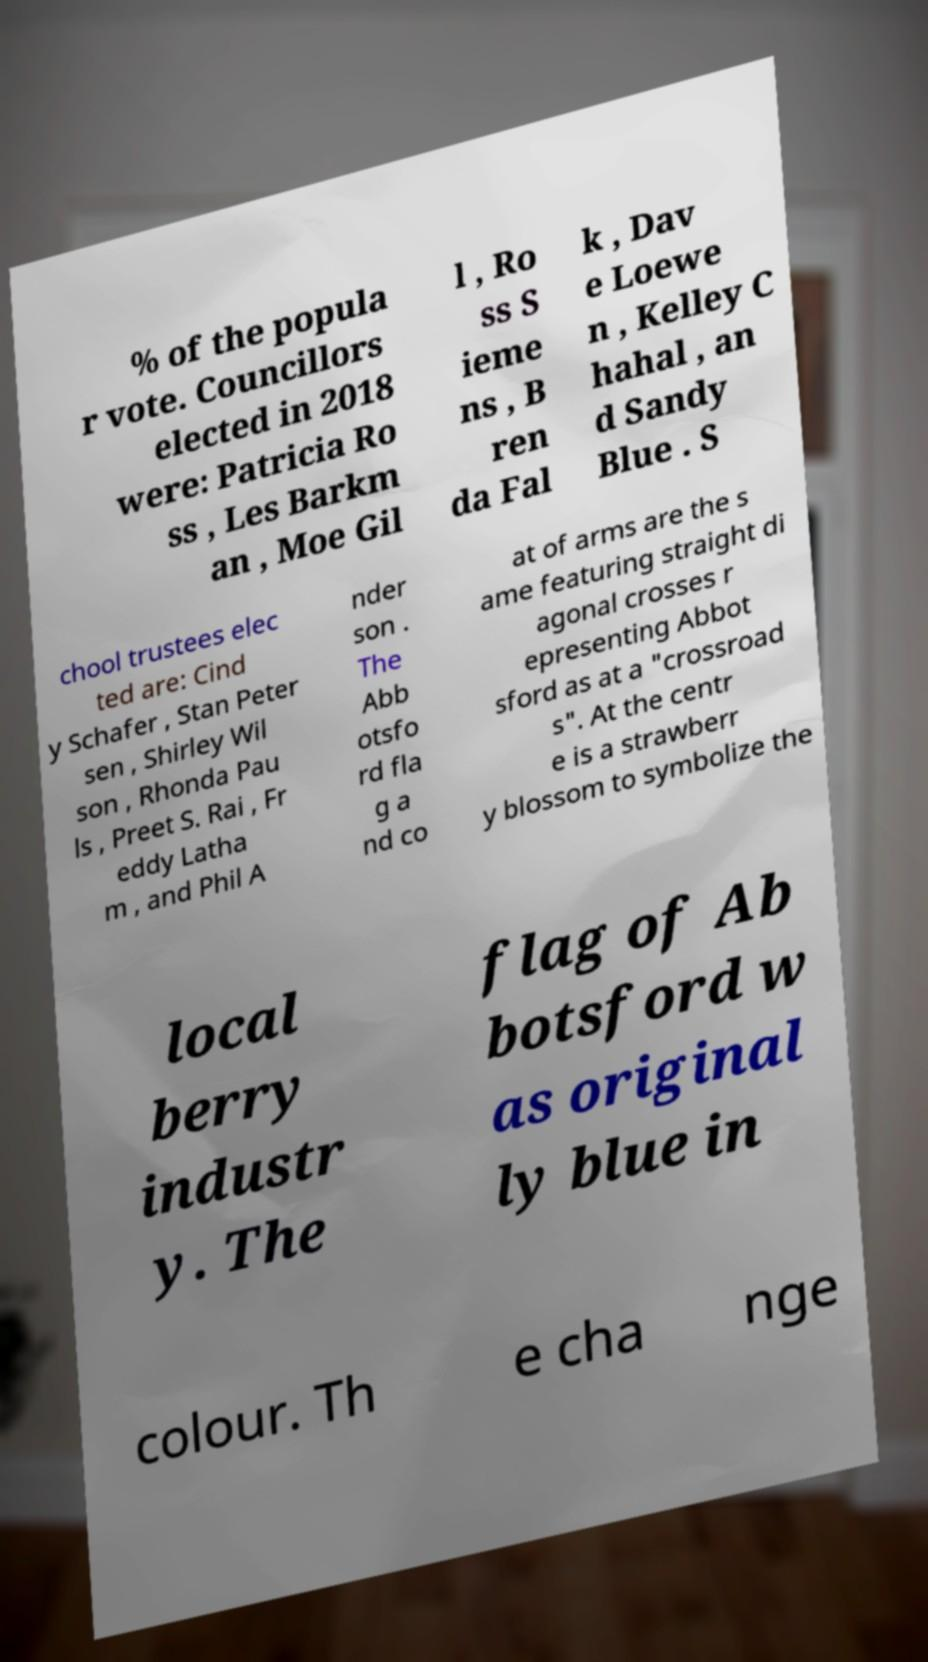Can you accurately transcribe the text from the provided image for me? % of the popula r vote. Councillors elected in 2018 were: Patricia Ro ss , Les Barkm an , Moe Gil l , Ro ss S ieme ns , B ren da Fal k , Dav e Loewe n , Kelley C hahal , an d Sandy Blue . S chool trustees elec ted are: Cind y Schafer , Stan Peter sen , Shirley Wil son , Rhonda Pau ls , Preet S. Rai , Fr eddy Latha m , and Phil A nder son . The Abb otsfo rd fla g a nd co at of arms are the s ame featuring straight di agonal crosses r epresenting Abbot sford as at a "crossroad s". At the centr e is a strawberr y blossom to symbolize the local berry industr y. The flag of Ab botsford w as original ly blue in colour. Th e cha nge 